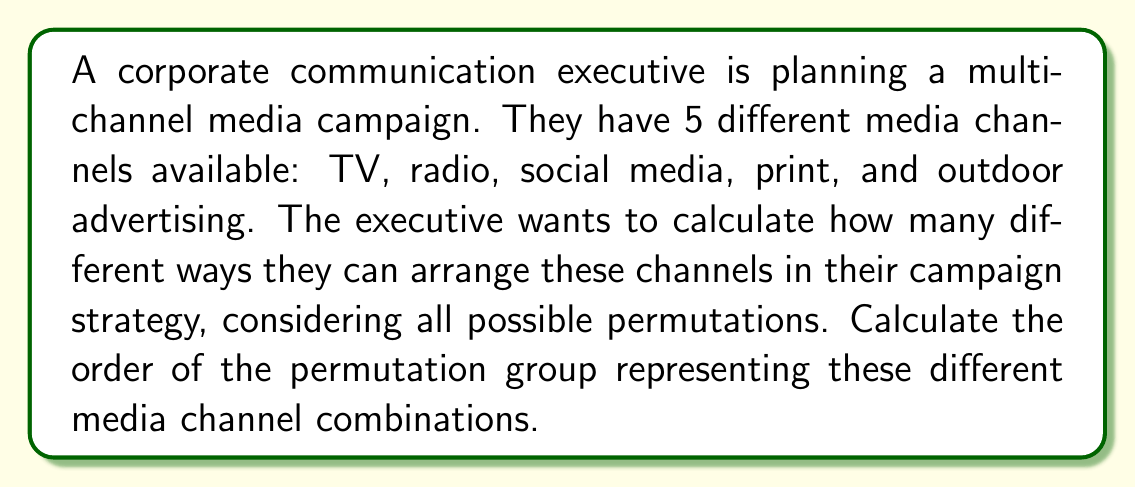Help me with this question. To solve this problem, we need to understand the concept of permutation groups in Group theory.

1) In this case, we have 5 distinct elements (TV, radio, social media, print, and outdoor advertising) that can be arranged in any order.

2) The number of permutations of n distinct objects is given by n!. This is also the order of the symmetric group $S_n$.

3) In our case, n = 5, so we need to calculate 5!.

4) Let's break this down step-by-step:

   $$5! = 5 \times 4 \times 3 \times 2 \times 1$$

5) Let's multiply these numbers:

   $$5! = 5 \times 4 \times 3 \times 2 \times 1 = 120$$

6) Therefore, the order of the permutation group representing all possible arrangements of these 5 media channels is 120.

This means the corporate communication executive has 120 different ways to arrange these 5 media channels in their campaign strategy.
Answer: The order of the permutation group is 120. 